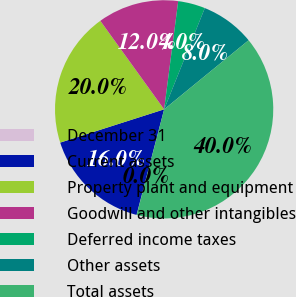<chart> <loc_0><loc_0><loc_500><loc_500><pie_chart><fcel>December 31<fcel>Current assets<fcel>Property plant and equipment<fcel>Goodwill and other intangibles<fcel>Deferred income taxes<fcel>Other assets<fcel>Total assets<nl><fcel>0.02%<fcel>16.0%<fcel>19.99%<fcel>12.0%<fcel>4.02%<fcel>8.01%<fcel>39.96%<nl></chart> 